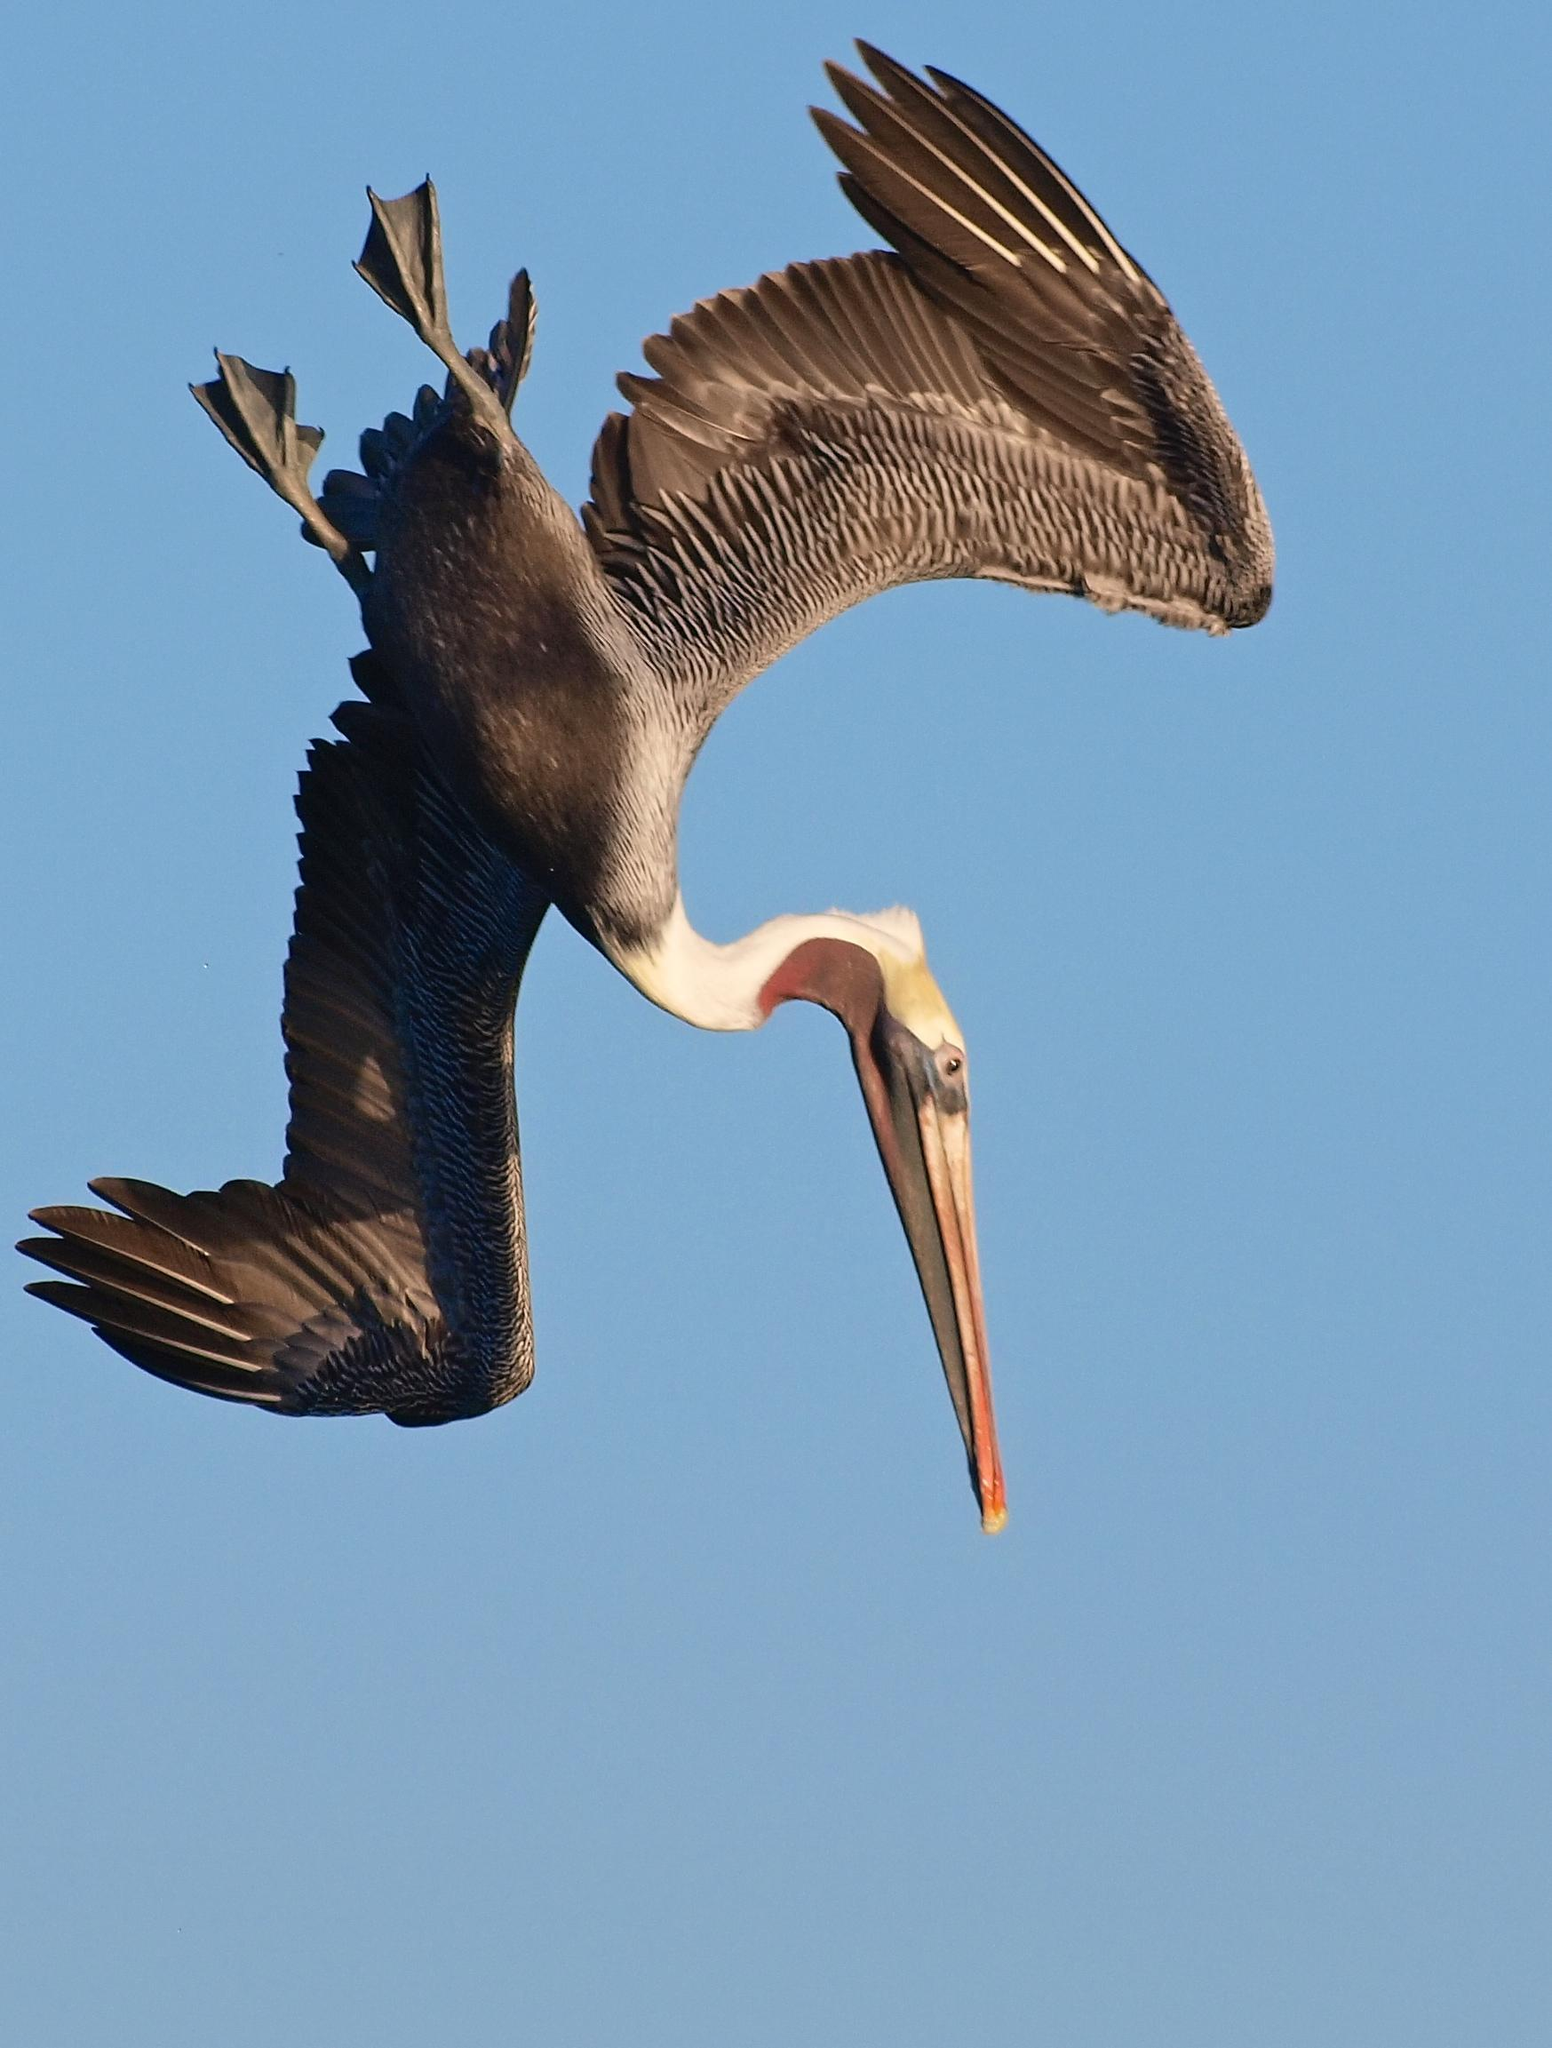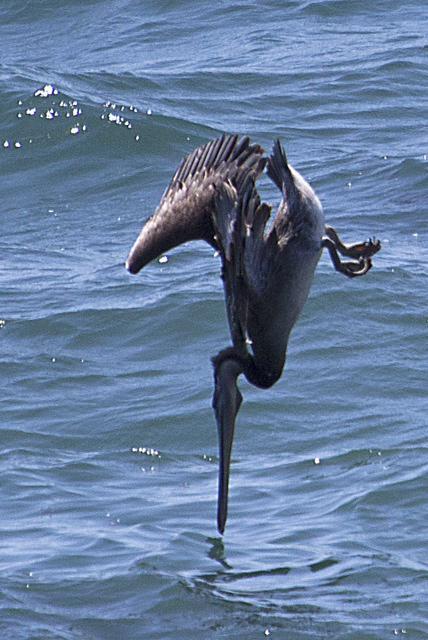The first image is the image on the left, the second image is the image on the right. Analyze the images presented: Is the assertion "Both images show diving pelicans, and the birds in the left and right images have their heads facing toward each other." valid? Answer yes or no. Yes. 